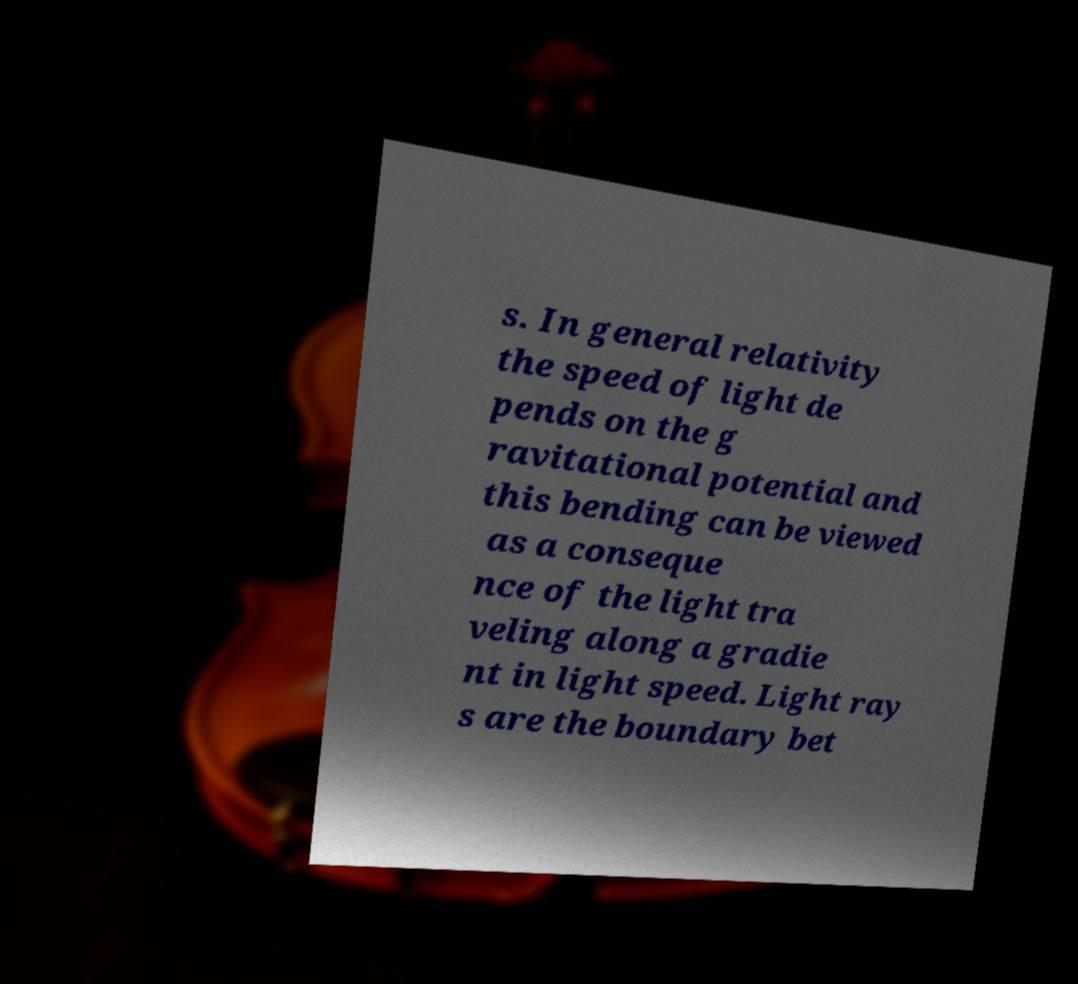Can you accurately transcribe the text from the provided image for me? s. In general relativity the speed of light de pends on the g ravitational potential and this bending can be viewed as a conseque nce of the light tra veling along a gradie nt in light speed. Light ray s are the boundary bet 